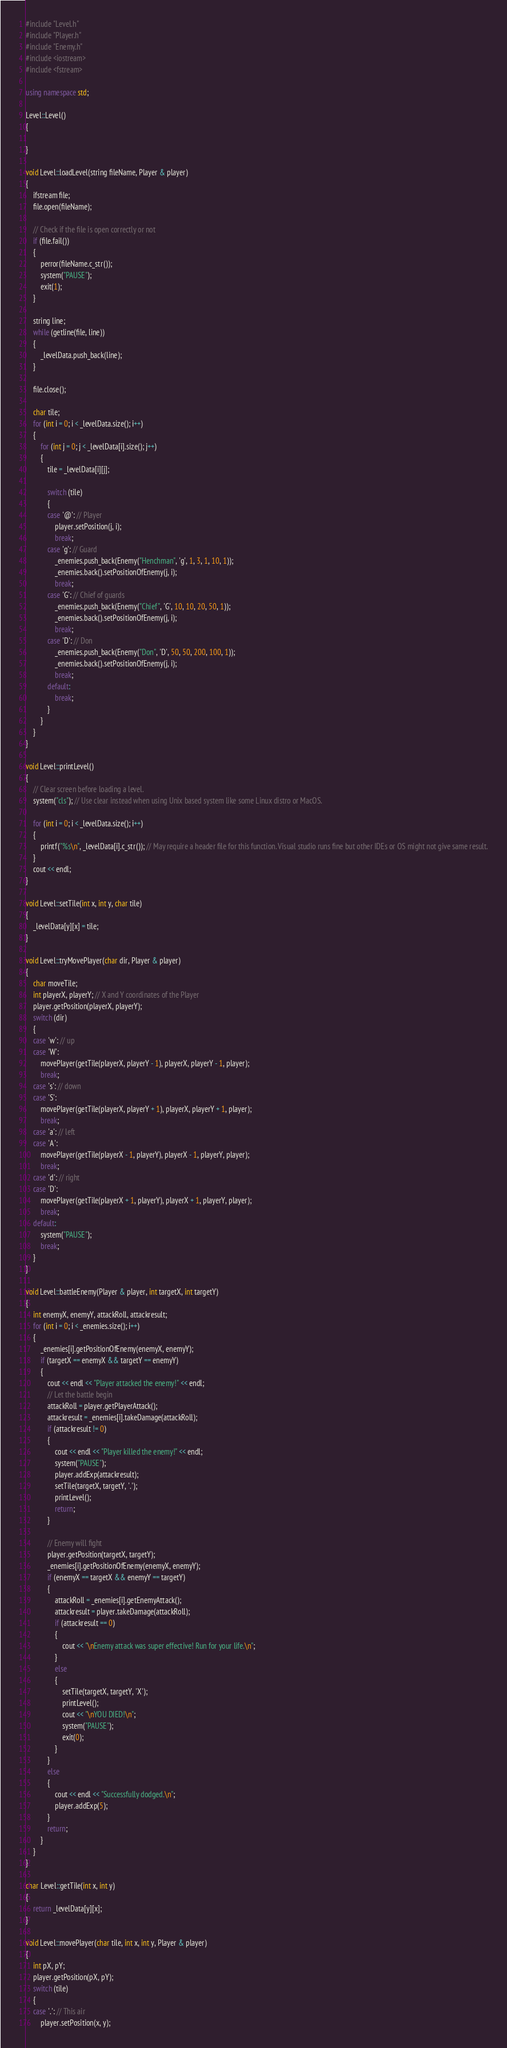<code> <loc_0><loc_0><loc_500><loc_500><_C++_>#include "Level.h"
#include "Player.h"
#include "Enemy.h"
#include <iostream>
#include <fstream>

using namespace std;

Level::Level()
{

}

void Level::loadLevel(string fileName, Player & player)
{
	ifstream file;
	file.open(fileName);

	// Check if the file is open correctly or not
	if (file.fail())
	{
		perror(fileName.c_str());
		system("PAUSE");
		exit(1);
	}

	string line;
	while (getline(file, line))
	{
		_levelData.push_back(line);
	}

	file.close();

	char tile;
	for (int i = 0; i < _levelData.size(); i++)
	{
		for (int j = 0; j < _levelData[i].size(); j++)
		{
			tile = _levelData[i][j];

			switch (tile)
			{
			case '@': // Player
				player.setPosition(j, i);
				break;
			case 'g': // Guard
				_enemies.push_back(Enemy("Henchman", 'g', 1, 3, 1, 10, 1));
				_enemies.back().setPositionOfEnemy(j, i);
				break;
			case 'G': // Chief of guards
				_enemies.push_back(Enemy("Chief", 'G', 10, 10, 20, 50, 1));
				_enemies.back().setPositionOfEnemy(j, i);
				break;
			case 'D': // Don
				_enemies.push_back(Enemy("Don", 'D', 50, 50, 200, 100, 1));
				_enemies.back().setPositionOfEnemy(j, i);
				break;
			default:
				break;
			}
		}
	}
}

void Level::printLevel()
{
	// Clear screen before loading a level.
	system("cls"); // Use clear instead when using Unix based system like some Linux distro or MacOS. 

	for (int i = 0; i < _levelData.size(); i++)
	{
		printf("%s\n", _levelData[i].c_str()); // May require a header file for this function. Visual studio runs fine but other IDEs or OS might not give same result.
	}
	cout << endl;
}

void Level::setTile(int x, int y, char tile)
{
	_levelData[y][x] = tile;
}

void Level::tryMovePlayer(char dir, Player & player)
{
	char moveTile;
	int playerX, playerY; // X and Y coordinates of the Player
	player.getPosition(playerX, playerY);
	switch (dir)
	{
	case 'w': // up
	case 'W':
		movePlayer(getTile(playerX, playerY - 1), playerX, playerY - 1, player);
		break;
	case 's': // down
	case 'S':
		movePlayer(getTile(playerX, playerY + 1), playerX, playerY + 1, player);
		break;
	case 'a': // left
	case 'A':
		movePlayer(getTile(playerX - 1, playerY), playerX - 1, playerY, player);
		break;
	case 'd': // right
	case 'D':
		movePlayer(getTile(playerX + 1, playerY), playerX + 1, playerY, player);
		break;
	default:
		system("PAUSE");
		break;
	}
}

void Level::battleEnemy(Player & player, int targetX, int targetY)
{
	int enemyX, enemyY, attackRoll, attackresult;
	for (int i = 0; i < _enemies.size(); i++)
	{
		_enemies[i].getPositionOfEnemy(enemyX, enemyY);
		if (targetX == enemyX && targetY == enemyY)
		{
			cout << endl << "Player attacked the enemy!" << endl;
			// Let the battle begin
			attackRoll = player.getPlayerAttack();
			attackresult = _enemies[i].takeDamage(attackRoll);
			if (attackresult != 0)
			{
				cout << endl << "Player killed the enemy!" << endl;
				system("PAUSE");
				player.addExp(attackresult);
				setTile(targetX, targetY, '.');
				printLevel();
				return;
			}
			
			// Enemy will fight
			player.getPosition(targetX, targetY);
			_enemies[i].getPositionOfEnemy(enemyX, enemyY);
			if (enemyX == targetX && enemyY == targetY)
			{
				attackRoll = _enemies[i].getEnemyAttack();
				attackresult = player.takeDamage(attackRoll);
				if (attackresult == 0)
				{
					cout << "\nEnemy attack was super effective! Run for your life.\n";
				}
				else
				{
					setTile(targetX, targetY, 'X');
					printLevel();
					cout << "\nYOU DIED!\n";
					system("PAUSE");
					exit(0);
				}
			}
			else
			{
				cout << endl << "Successfully dodged.\n";
				player.addExp(5);
			}
			return;
		}
	}
}

char Level::getTile(int x, int y)
{
	return _levelData[y][x];
}

void Level::movePlayer(char tile, int x, int y, Player & player)
{
	int pX, pY;
	player.getPosition(pX, pY);
	switch (tile)
	{
	case '.': // This air
		player.setPosition(x, y);</code> 